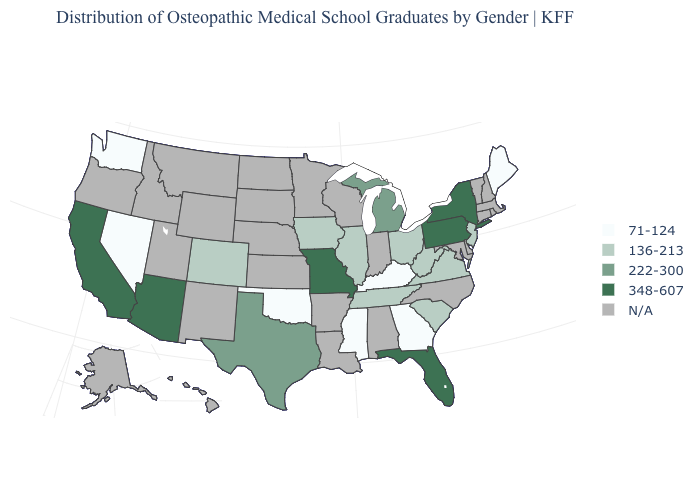Does the map have missing data?
Concise answer only. Yes. What is the value of Texas?
Keep it brief. 222-300. How many symbols are there in the legend?
Answer briefly. 5. Does Maine have the highest value in the USA?
Concise answer only. No. What is the lowest value in the USA?
Quick response, please. 71-124. Name the states that have a value in the range 71-124?
Give a very brief answer. Georgia, Kentucky, Maine, Mississippi, Nevada, Oklahoma, Washington. How many symbols are there in the legend?
Answer briefly. 5. Among the states that border North Carolina , which have the highest value?
Quick response, please. South Carolina, Tennessee, Virginia. What is the value of Pennsylvania?
Quick response, please. 348-607. Name the states that have a value in the range 136-213?
Write a very short answer. Colorado, Illinois, Iowa, New Jersey, Ohio, South Carolina, Tennessee, Virginia, West Virginia. What is the value of Connecticut?
Concise answer only. N/A. Name the states that have a value in the range 348-607?
Short answer required. Arizona, California, Florida, Missouri, New York, Pennsylvania. Name the states that have a value in the range 71-124?
Quick response, please. Georgia, Kentucky, Maine, Mississippi, Nevada, Oklahoma, Washington. 